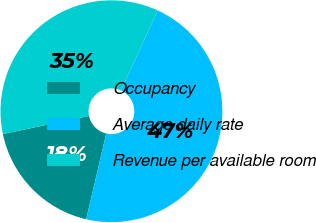Convert chart. <chart><loc_0><loc_0><loc_500><loc_500><pie_chart><fcel>Occupancy<fcel>Average daily rate<fcel>Revenue per available room<nl><fcel>18.06%<fcel>46.79%<fcel>35.15%<nl></chart> 